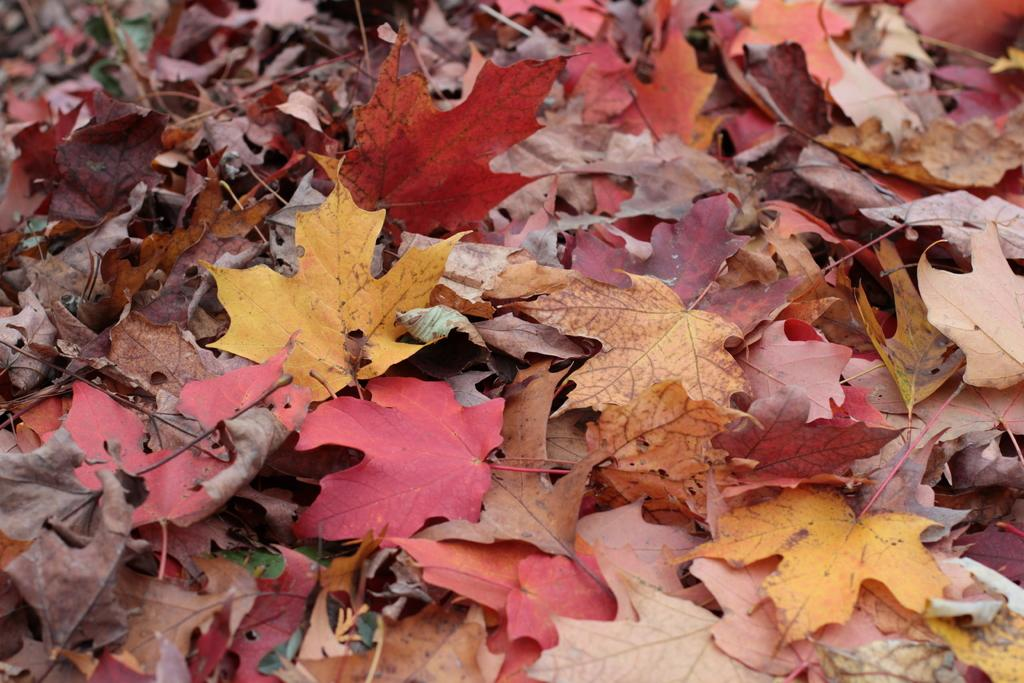What type of vegetation can be seen in the image? There are leaves in the image. What type of writing can be seen on the leaves in the image? There is no writing present on the leaves in the image. What type of beef dish is being prepared in the image? There is no beef dish or any food preparation visible in the image; it only contains leaves. 